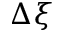<formula> <loc_0><loc_0><loc_500><loc_500>\Delta \xi</formula> 